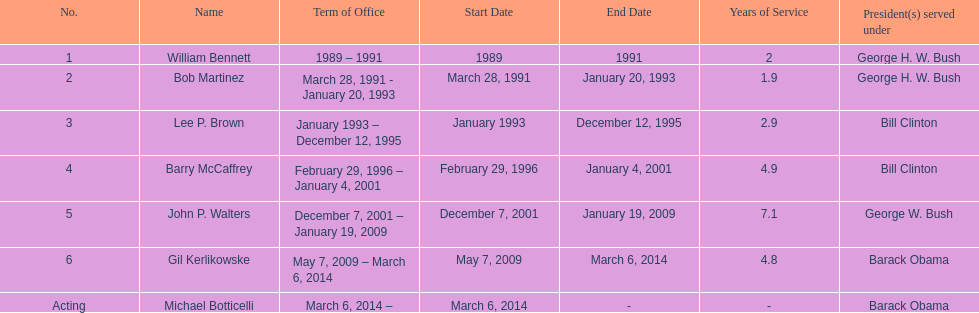Who was the next appointed director after lee p. brown? Barry McCaffrey. 